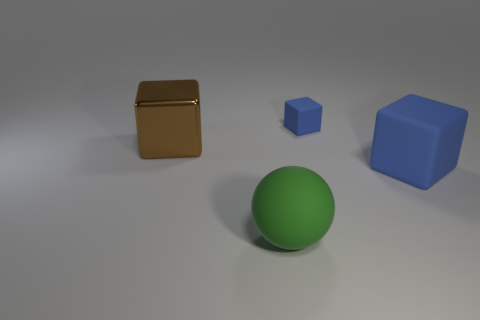Subtract all blue rubber cubes. How many cubes are left? 1 Subtract 1 balls. How many balls are left? 0 Add 2 brown cubes. How many objects exist? 6 Subtract all brown cubes. How many cubes are left? 2 Subtract all cubes. How many objects are left? 1 Subtract 0 gray blocks. How many objects are left? 4 Subtract all green blocks. Subtract all blue cylinders. How many blocks are left? 3 Subtract all cyan spheres. How many brown blocks are left? 1 Subtract all small blue objects. Subtract all big blue objects. How many objects are left? 2 Add 3 large blue cubes. How many large blue cubes are left? 4 